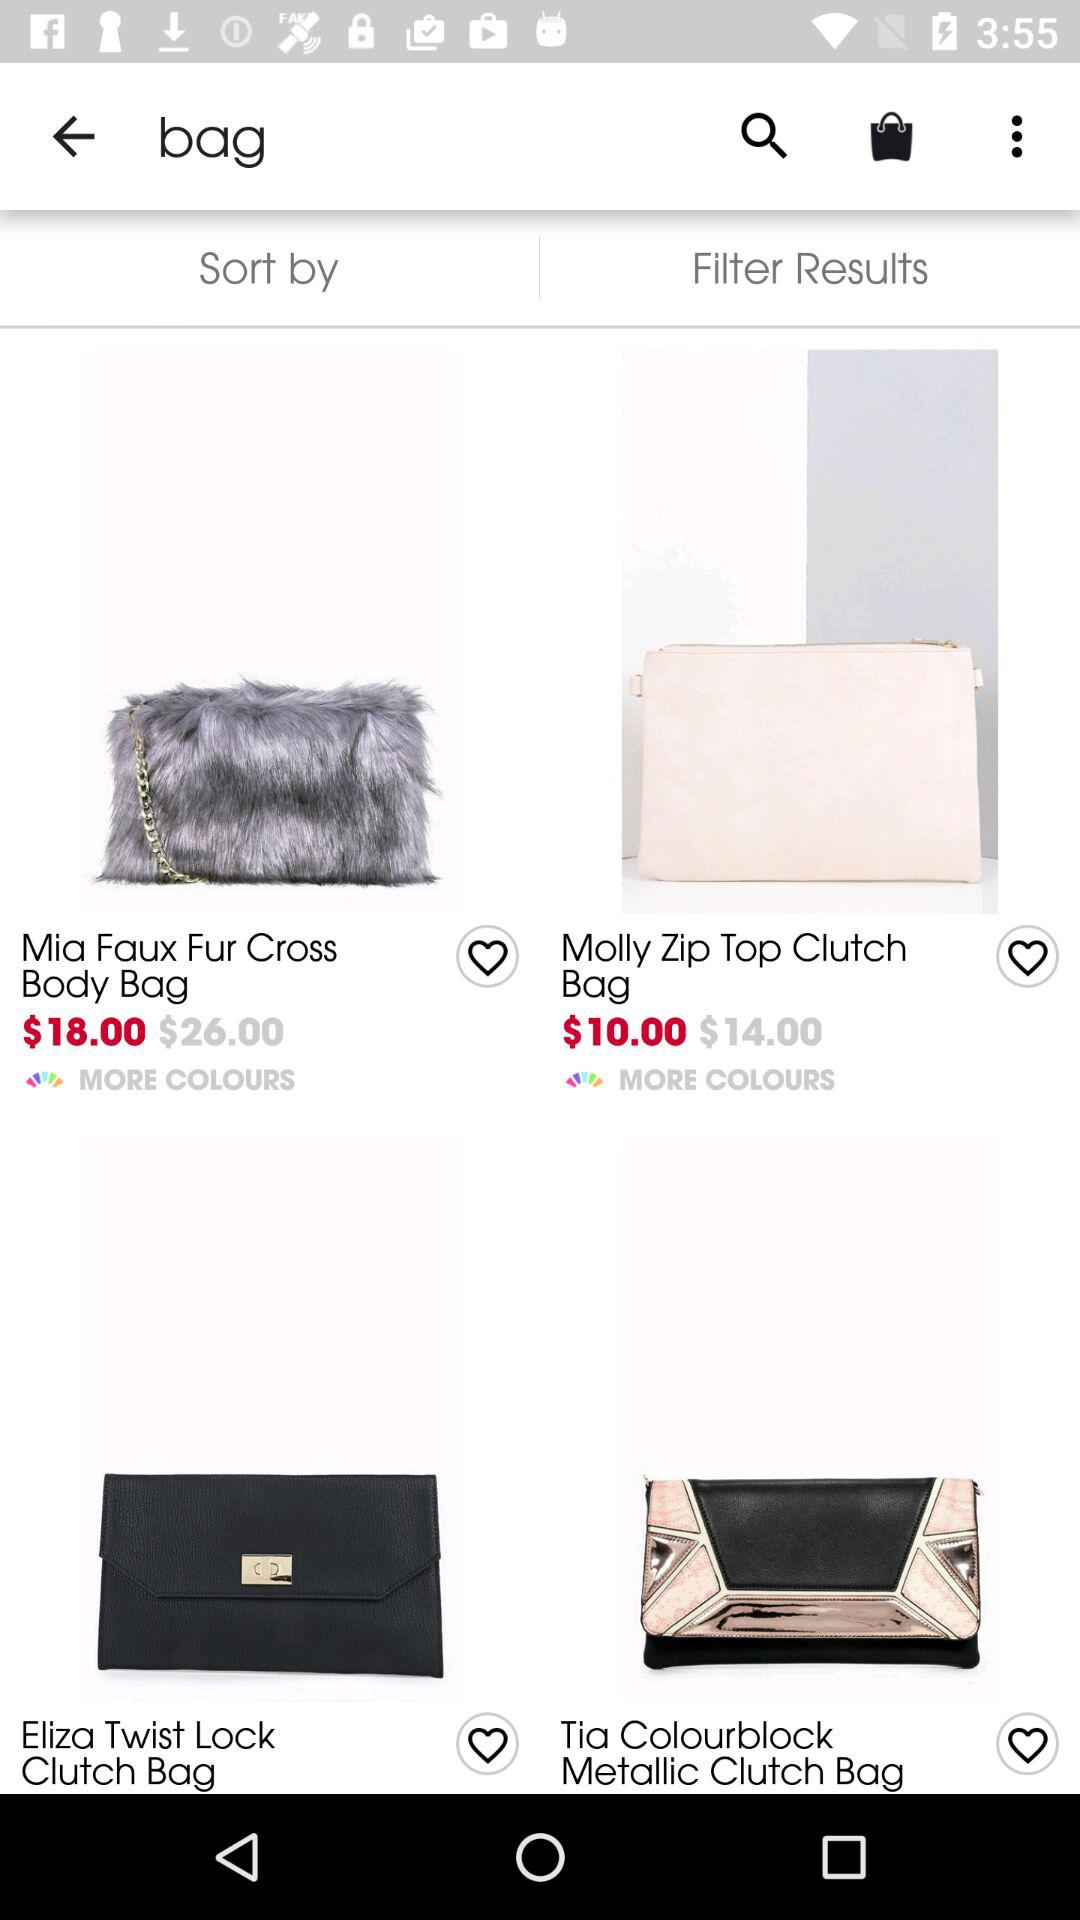How many items are in the bag?
When the provided information is insufficient, respond with <no answer>. <no answer> 